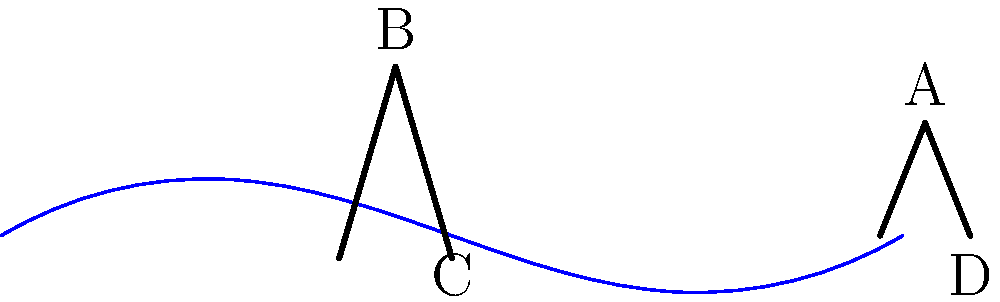In the traditional Venetian gondola decoration shown above, identify the pair of congruent elements and explain their significance in gondola design and Venetian culture. To answer this question, let's analyze the elements of the gondola decoration step-by-step:

1. The diagram shows a simplified side view of a Venetian gondola with two prominent decorative elements:
   a) The 'ferro' (iron) at the bow (front) of the gondola
   b) The 'forcola' (oarlock) near the middle of the gondola

2. The ferro is represented by the triangle ACD, while the forcola is represented by the triangle BCD.

3. These two triangles are congruent, as they share the same shape and approximate size. This congruence is not accidental but purposeful in Venetian gondola design.

4. The significance of these congruent elements:
   a) Functionality: Both the ferro and forcola serve important roles in gondola operation. The ferro acts as a counterweight and protection for the bow, while the forcola supports the oar for rowing.
   b) Symbolism: The ferro's shape represents the six sestieri (districts) of Venice, the Giudecca Island, and the Rialto Bridge. The forcola's shape echoes this symbolism, creating a visual harmony.
   c) Craftsmanship: The congruence demonstrates the skill of Venetian artisans in creating balanced, symmetrical designs.
   d) Cultural identity: These elements are unique to Venetian gondolas, serving as a symbol of Venetian maritime tradition and craftsmanship.

5. The congruence of these elements reflects the Venetian appreciation for balance, symmetry, and the integration of form and function in their traditional boat design.
Answer: Ferro (ACD) and forcola (BCD) 